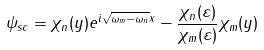Convert formula to latex. <formula><loc_0><loc_0><loc_500><loc_500>\psi _ { s c } = \chi _ { n } ( y ) e ^ { i \sqrt { \omega _ { m } - \omega _ { n } } x } - \frac { \chi _ { n } ( \varepsilon ) } { \chi _ { m } ( \varepsilon ) } \chi _ { m } ( y )</formula> 